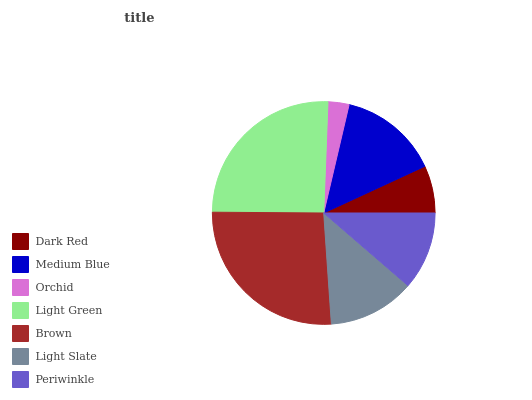Is Orchid the minimum?
Answer yes or no. Yes. Is Brown the maximum?
Answer yes or no. Yes. Is Medium Blue the minimum?
Answer yes or no. No. Is Medium Blue the maximum?
Answer yes or no. No. Is Medium Blue greater than Dark Red?
Answer yes or no. Yes. Is Dark Red less than Medium Blue?
Answer yes or no. Yes. Is Dark Red greater than Medium Blue?
Answer yes or no. No. Is Medium Blue less than Dark Red?
Answer yes or no. No. Is Light Slate the high median?
Answer yes or no. Yes. Is Light Slate the low median?
Answer yes or no. Yes. Is Dark Red the high median?
Answer yes or no. No. Is Medium Blue the low median?
Answer yes or no. No. 